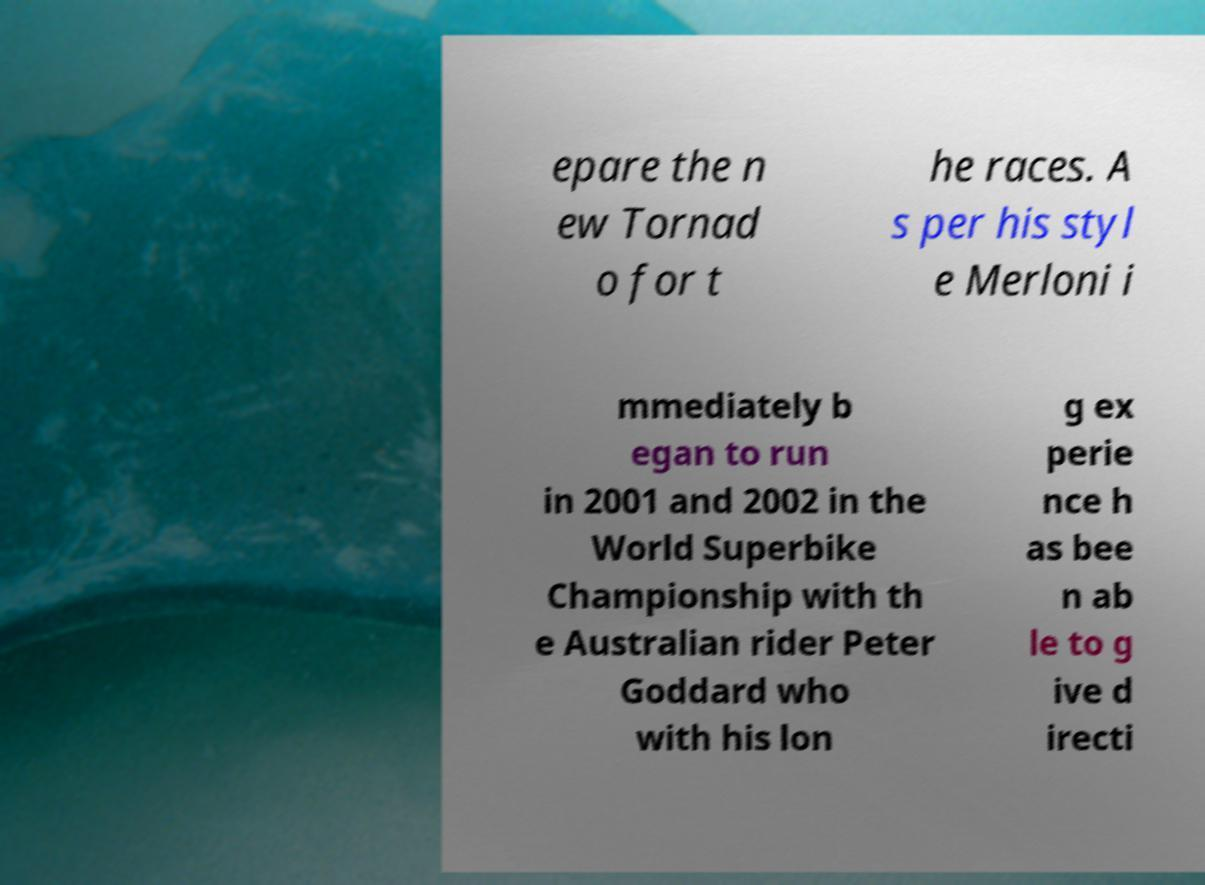There's text embedded in this image that I need extracted. Can you transcribe it verbatim? epare the n ew Tornad o for t he races. A s per his styl e Merloni i mmediately b egan to run in 2001 and 2002 in the World Superbike Championship with th e Australian rider Peter Goddard who with his lon g ex perie nce h as bee n ab le to g ive d irecti 